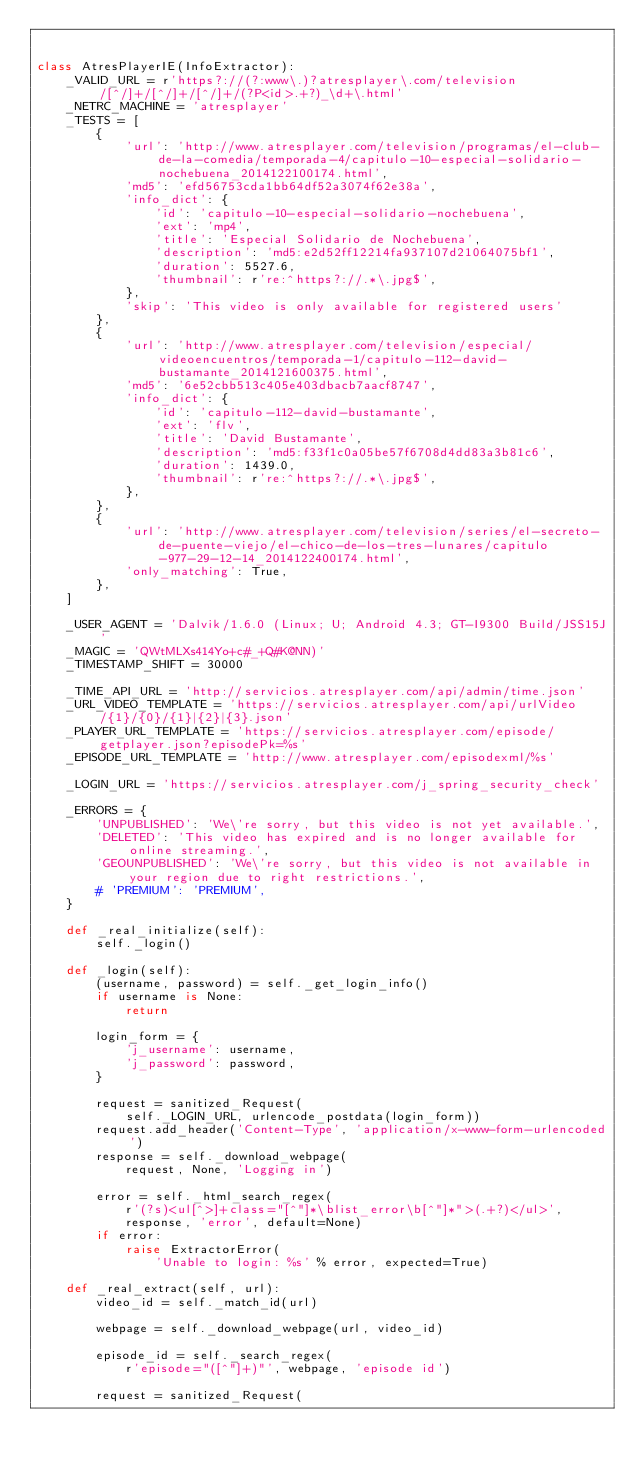<code> <loc_0><loc_0><loc_500><loc_500><_Python_>

class AtresPlayerIE(InfoExtractor):
    _VALID_URL = r'https?://(?:www\.)?atresplayer\.com/television/[^/]+/[^/]+/[^/]+/(?P<id>.+?)_\d+\.html'
    _NETRC_MACHINE = 'atresplayer'
    _TESTS = [
        {
            'url': 'http://www.atresplayer.com/television/programas/el-club-de-la-comedia/temporada-4/capitulo-10-especial-solidario-nochebuena_2014122100174.html',
            'md5': 'efd56753cda1bb64df52a3074f62e38a',
            'info_dict': {
                'id': 'capitulo-10-especial-solidario-nochebuena',
                'ext': 'mp4',
                'title': 'Especial Solidario de Nochebuena',
                'description': 'md5:e2d52ff12214fa937107d21064075bf1',
                'duration': 5527.6,
                'thumbnail': r're:^https?://.*\.jpg$',
            },
            'skip': 'This video is only available for registered users'
        },
        {
            'url': 'http://www.atresplayer.com/television/especial/videoencuentros/temporada-1/capitulo-112-david-bustamante_2014121600375.html',
            'md5': '6e52cbb513c405e403dbacb7aacf8747',
            'info_dict': {
                'id': 'capitulo-112-david-bustamante',
                'ext': 'flv',
                'title': 'David Bustamante',
                'description': 'md5:f33f1c0a05be57f6708d4dd83a3b81c6',
                'duration': 1439.0,
                'thumbnail': r're:^https?://.*\.jpg$',
            },
        },
        {
            'url': 'http://www.atresplayer.com/television/series/el-secreto-de-puente-viejo/el-chico-de-los-tres-lunares/capitulo-977-29-12-14_2014122400174.html',
            'only_matching': True,
        },
    ]

    _USER_AGENT = 'Dalvik/1.6.0 (Linux; U; Android 4.3; GT-I9300 Build/JSS15J'
    _MAGIC = 'QWtMLXs414Yo+c#_+Q#K@NN)'
    _TIMESTAMP_SHIFT = 30000

    _TIME_API_URL = 'http://servicios.atresplayer.com/api/admin/time.json'
    _URL_VIDEO_TEMPLATE = 'https://servicios.atresplayer.com/api/urlVideo/{1}/{0}/{1}|{2}|{3}.json'
    _PLAYER_URL_TEMPLATE = 'https://servicios.atresplayer.com/episode/getplayer.json?episodePk=%s'
    _EPISODE_URL_TEMPLATE = 'http://www.atresplayer.com/episodexml/%s'

    _LOGIN_URL = 'https://servicios.atresplayer.com/j_spring_security_check'

    _ERRORS = {
        'UNPUBLISHED': 'We\'re sorry, but this video is not yet available.',
        'DELETED': 'This video has expired and is no longer available for online streaming.',
        'GEOUNPUBLISHED': 'We\'re sorry, but this video is not available in your region due to right restrictions.',
        # 'PREMIUM': 'PREMIUM',
    }

    def _real_initialize(self):
        self._login()

    def _login(self):
        (username, password) = self._get_login_info()
        if username is None:
            return

        login_form = {
            'j_username': username,
            'j_password': password,
        }

        request = sanitized_Request(
            self._LOGIN_URL, urlencode_postdata(login_form))
        request.add_header('Content-Type', 'application/x-www-form-urlencoded')
        response = self._download_webpage(
            request, None, 'Logging in')

        error = self._html_search_regex(
            r'(?s)<ul[^>]+class="[^"]*\blist_error\b[^"]*">(.+?)</ul>',
            response, 'error', default=None)
        if error:
            raise ExtractorError(
                'Unable to login: %s' % error, expected=True)

    def _real_extract(self, url):
        video_id = self._match_id(url)

        webpage = self._download_webpage(url, video_id)

        episode_id = self._search_regex(
            r'episode="([^"]+)"', webpage, 'episode id')

        request = sanitized_Request(</code> 